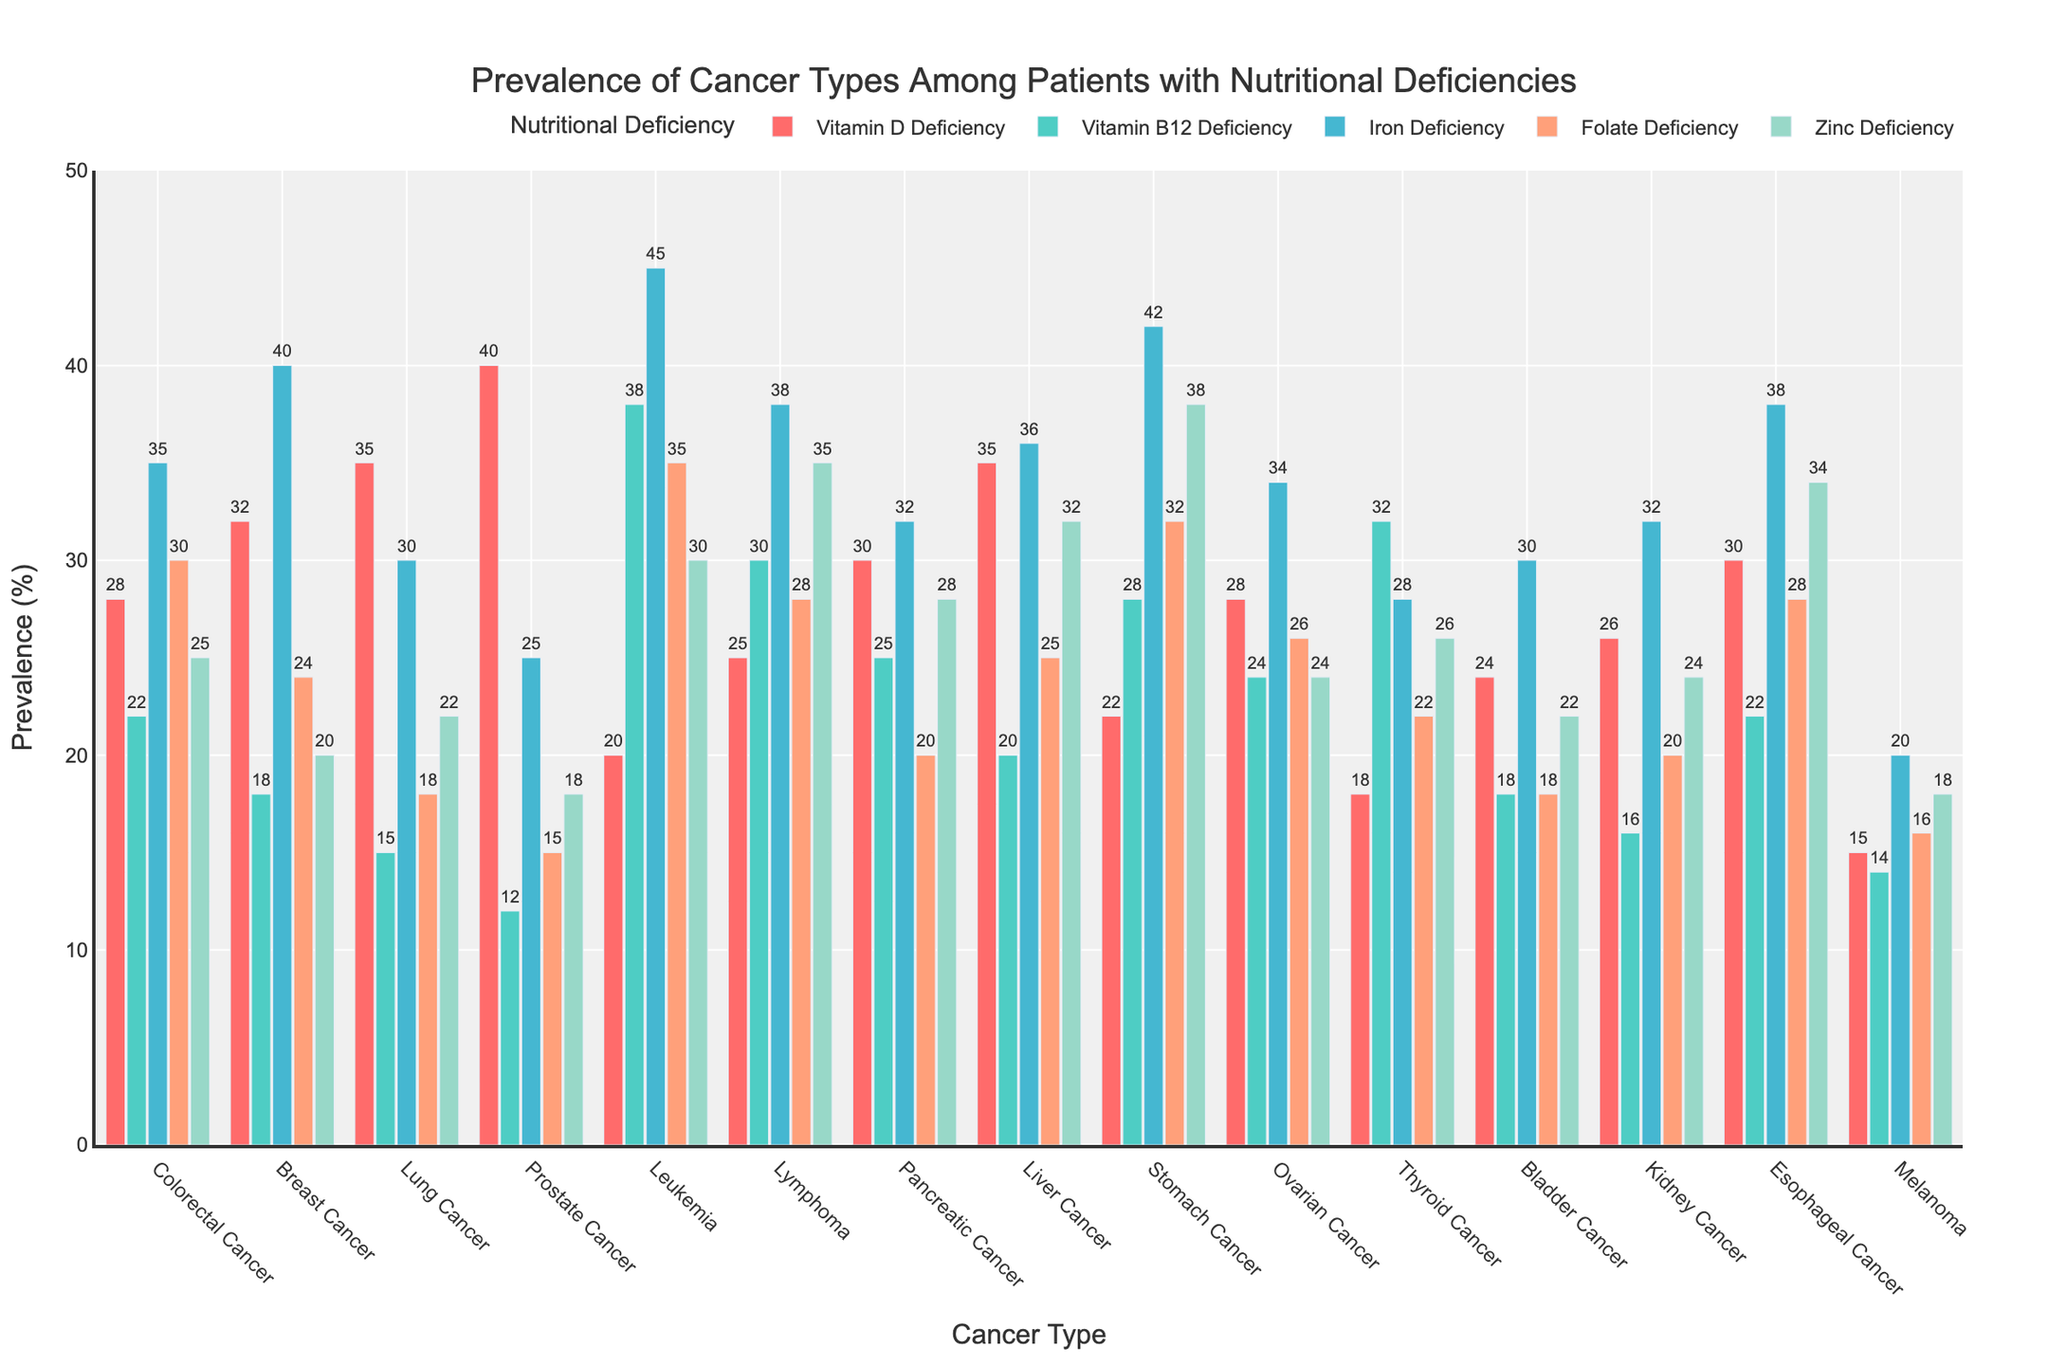Which cancer type shows the highest prevalence with a Vitamin D Deficiency? The bar for Prostate Cancer is the tallest among the bars representing Vitamin D Deficiency, indicating it has the highest prevalence in this category.
Answer: Prostate Cancer Which nutritional deficiency has the highest prevalence among Leukemia patients? The tallest bar for Leukemia patients is for Iron Deficiency, hence it has the highest prevalence.
Answer: Iron Deficiency What is the combined prevalence of Vitamin B12 Deficiency in Breast Cancer and Stomach Cancer patients? Sum the prevalence values of Vitamin B12 Deficiency for Breast Cancer (18) and Stomach Cancer (28): 18 + 28 = 46.
Answer: 46 Which cancer type has a higher prevalence of Zinc Deficiency, Stomach Cancer or Esophageal Cancer? The bar for Zinc Deficiency is taller for Stomach Cancer (38) compared to Esophageal Cancer (34).
Answer: Stomach Cancer Compare the prevalence of Iron Deficiency between Lung Cancer and Liver Cancer patients. Which is higher? The bar for Iron Deficiency is taller for Liver Cancer (36) compared to Lung Cancer (30).
Answer: Liver Cancer How does the prevalence of Folate Deficiency in Pancreatic Cancer compare to Bladder Cancer? Pancreatic Cancer has a higher Folate Deficiency prevalence (20) compared to Bladder Cancer (18).
Answer: Pancreatic Cancer What is the average prevalence of nutritional deficiencies among Melanoma patients? Add the prevalence values for Melanoma and divide by the number of nutritional deficiencies: (15+14+20+16+18)/5 = 16.6.
Answer: 16.6 Which cancer types have a prevalence of Vitamin D Deficiency equal to 35%? The bars for Lung Cancer and Liver Cancer regarding Vitamin D Deficiency both reach 35%.
Answer: Lung Cancer, Liver Cancer What deficiency has the second highest prevalence in Thyroid Cancer patients? The order of deficiency bars for Thyroid Cancer from highest to lowest: B12 (32), Zinc (26), Iron (28), D (18), Folate (22). Zinc is second.
Answer: Zinc Deficiency In terms of Vitamin B12 Deficiency, which cancer type has the lowest prevalence? The shortest bar for Vitamin B12 Deficiency is seen in Prostate Cancer with a value of 12.
Answer: Prostate Cancer 